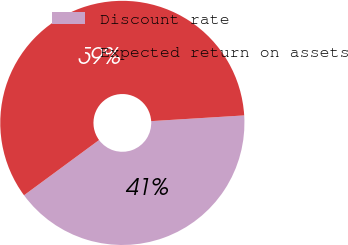Convert chart. <chart><loc_0><loc_0><loc_500><loc_500><pie_chart><fcel>Discount rate<fcel>Expected return on assets<nl><fcel>40.88%<fcel>59.12%<nl></chart> 